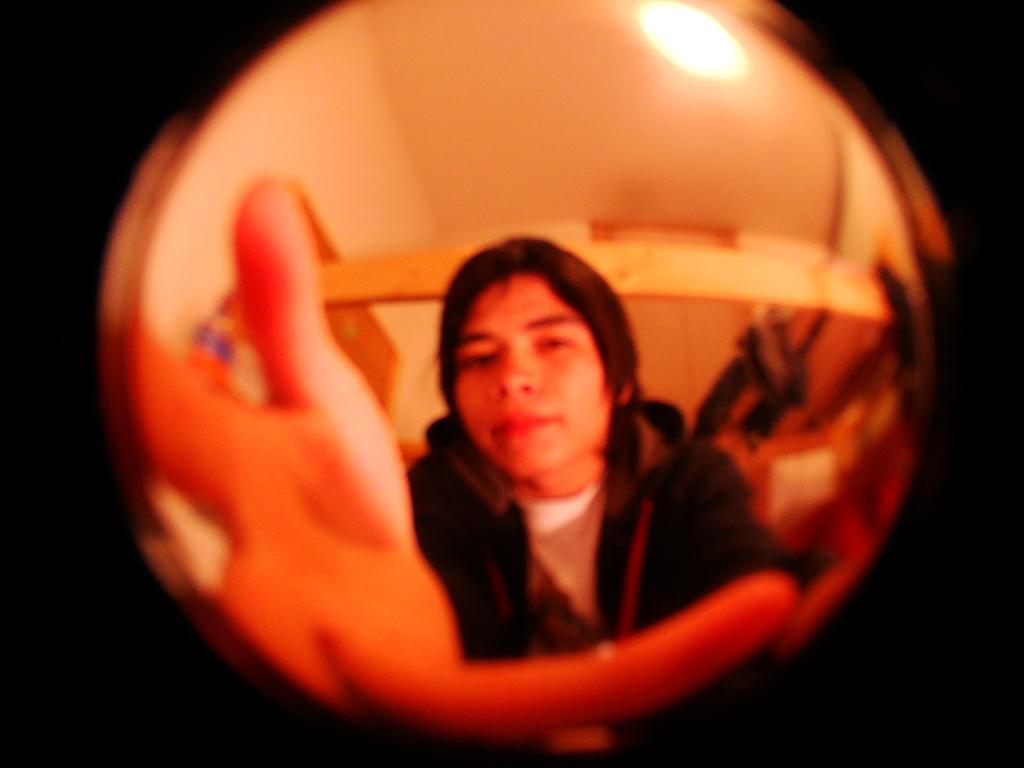Can you describe this image briefly? In this image there is a man, there is roof towards the top of the image, there is a wall, there is a light, the background of the image is dark. 